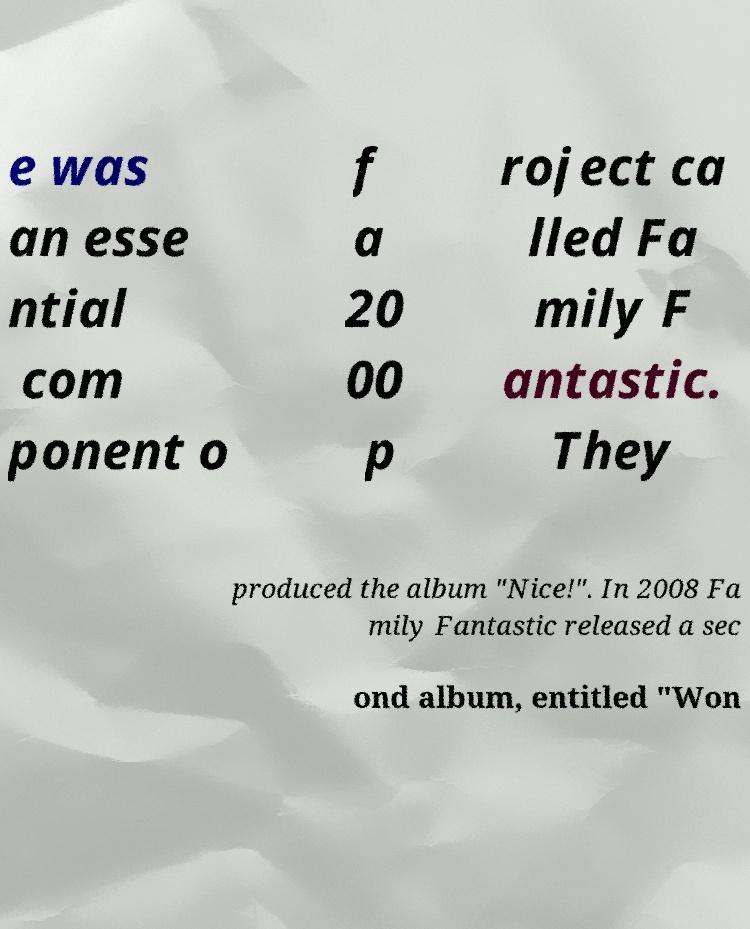Can you read and provide the text displayed in the image?This photo seems to have some interesting text. Can you extract and type it out for me? e was an esse ntial com ponent o f a 20 00 p roject ca lled Fa mily F antastic. They produced the album "Nice!". In 2008 Fa mily Fantastic released a sec ond album, entitled "Won 